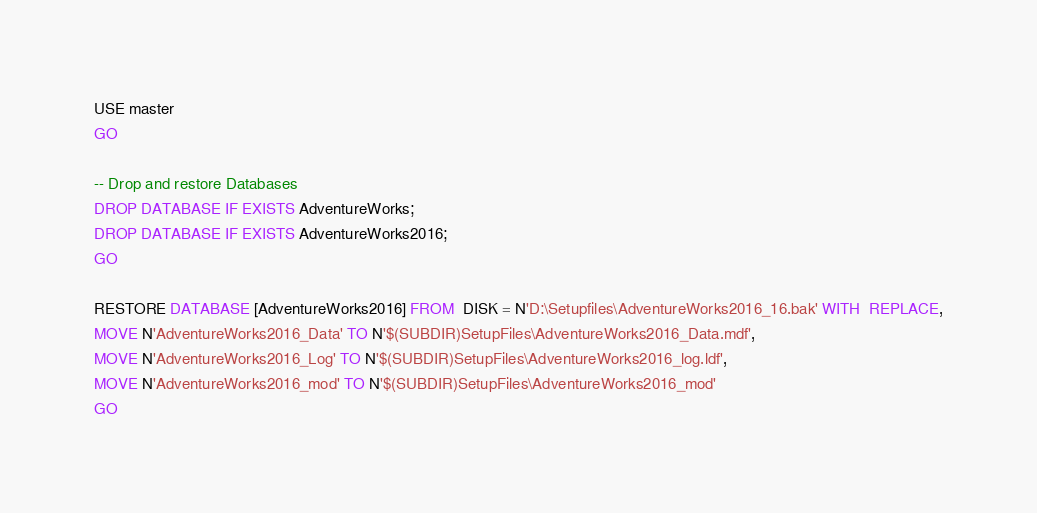<code> <loc_0><loc_0><loc_500><loc_500><_SQL_>USE master
GO

-- Drop and restore Databases
DROP DATABASE IF EXISTS AdventureWorks;
DROP DATABASE IF EXISTS AdventureWorks2016;
GO

RESTORE DATABASE [AdventureWorks2016] FROM  DISK = N'D:\Setupfiles\AdventureWorks2016_16.bak' WITH  REPLACE,
MOVE N'AdventureWorks2016_Data' TO N'$(SUBDIR)SetupFiles\AdventureWorks2016_Data.mdf', 
MOVE N'AdventureWorks2016_Log' TO N'$(SUBDIR)SetupFiles\AdventureWorks2016_log.ldf',
MOVE N'AdventureWorks2016_mod' TO N'$(SUBDIR)SetupFiles\AdventureWorks2016_mod'
GO
</code> 